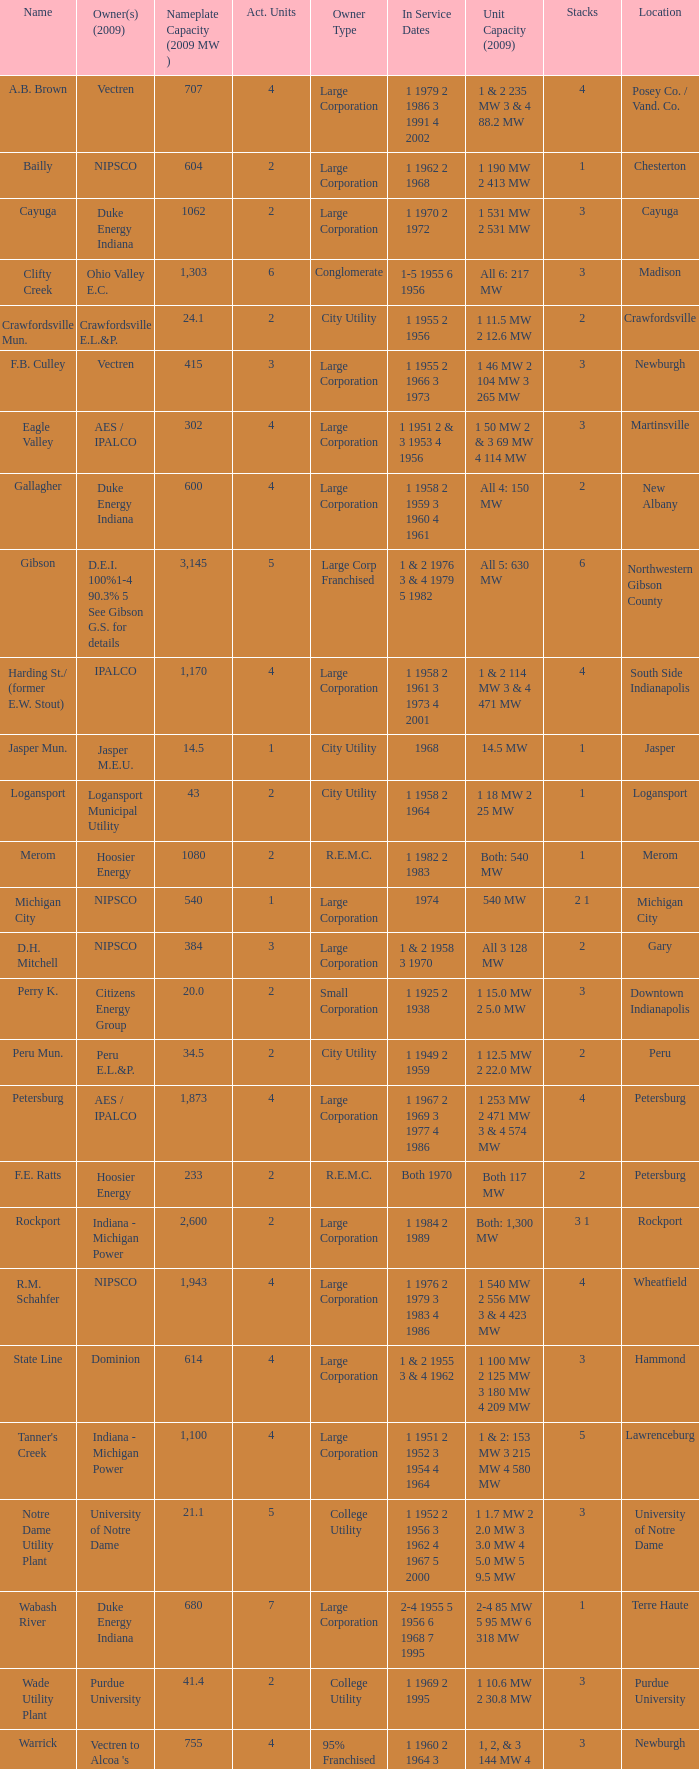Parse the full table. {'header': ['Name', 'Owner(s) (2009)', 'Nameplate Capacity (2009 MW )', 'Act. Units', 'Owner Type', 'In Service Dates', 'Unit Capacity (2009)', 'Stacks', 'Location'], 'rows': [['A.B. Brown', 'Vectren', '707', '4', 'Large Corporation', '1 1979 2 1986 3 1991 4 2002', '1 & 2 235 MW 3 & 4 88.2 MW', '4', 'Posey Co. / Vand. Co.'], ['Bailly', 'NIPSCO', '604', '2', 'Large Corporation', '1 1962 2 1968', '1 190 MW 2 413 MW', '1', 'Chesterton'], ['Cayuga', 'Duke Energy Indiana', '1062', '2', 'Large Corporation', '1 1970 2 1972', '1 531 MW 2 531 MW', '3', 'Cayuga'], ['Clifty Creek', 'Ohio Valley E.C.', '1,303', '6', 'Conglomerate', '1-5 1955 6 1956', 'All 6: 217 MW', '3', 'Madison'], ['Crawfordsville Mun.', 'Crawfordsville E.L.&P.', '24.1', '2', 'City Utility', '1 1955 2 1956', '1 11.5 MW 2 12.6 MW', '2', 'Crawfordsville'], ['F.B. Culley', 'Vectren', '415', '3', 'Large Corporation', '1 1955 2 1966 3 1973', '1 46 MW 2 104 MW 3 265 MW', '3', 'Newburgh'], ['Eagle Valley', 'AES / IPALCO', '302', '4', 'Large Corporation', '1 1951 2 & 3 1953 4 1956', '1 50 MW 2 & 3 69 MW 4 114 MW', '3', 'Martinsville'], ['Gallagher', 'Duke Energy Indiana', '600', '4', 'Large Corporation', '1 1958 2 1959 3 1960 4 1961', 'All 4: 150 MW', '2', 'New Albany'], ['Gibson', 'D.E.I. 100%1-4 90.3% 5 See Gibson G.S. for details', '3,145', '5', 'Large Corp Franchised', '1 & 2 1976 3 & 4 1979 5 1982', 'All 5: 630 MW', '6', 'Northwestern Gibson County'], ['Harding St./ (former E.W. Stout)', 'IPALCO', '1,170', '4', 'Large Corporation', '1 1958 2 1961 3 1973 4 2001', '1 & 2 114 MW 3 & 4 471 MW', '4', 'South Side Indianapolis'], ['Jasper Mun.', 'Jasper M.E.U.', '14.5', '1', 'City Utility', '1968', '14.5 MW', '1', 'Jasper'], ['Logansport', 'Logansport Municipal Utility', '43', '2', 'City Utility', '1 1958 2 1964', '1 18 MW 2 25 MW', '1', 'Logansport'], ['Merom', 'Hoosier Energy', '1080', '2', 'R.E.M.C.', '1 1982 2 1983', 'Both: 540 MW', '1', 'Merom'], ['Michigan City', 'NIPSCO', '540', '1', 'Large Corporation', '1974', '540 MW', '2 1', 'Michigan City'], ['D.H. Mitchell', 'NIPSCO', '384', '3', 'Large Corporation', '1 & 2 1958 3 1970', 'All 3 128 MW', '2', 'Gary'], ['Perry K.', 'Citizens Energy Group', '20.0', '2', 'Small Corporation', '1 1925 2 1938', '1 15.0 MW 2 5.0 MW', '3', 'Downtown Indianapolis'], ['Peru Mun.', 'Peru E.L.&P.', '34.5', '2', 'City Utility', '1 1949 2 1959', '1 12.5 MW 2 22.0 MW', '2', 'Peru'], ['Petersburg', 'AES / IPALCO', '1,873', '4', 'Large Corporation', '1 1967 2 1969 3 1977 4 1986', '1 253 MW 2 471 MW 3 & 4 574 MW', '4', 'Petersburg'], ['F.E. Ratts', 'Hoosier Energy', '233', '2', 'R.E.M.C.', 'Both 1970', 'Both 117 MW', '2', 'Petersburg'], ['Rockport', 'Indiana - Michigan Power', '2,600', '2', 'Large Corporation', '1 1984 2 1989', 'Both: 1,300 MW', '3 1', 'Rockport'], ['R.M. Schahfer', 'NIPSCO', '1,943', '4', 'Large Corporation', '1 1976 2 1979 3 1983 4 1986', '1 540 MW 2 556 MW 3 & 4 423 MW', '4', 'Wheatfield'], ['State Line', 'Dominion', '614', '4', 'Large Corporation', '1 & 2 1955 3 & 4 1962', '1 100 MW 2 125 MW 3 180 MW 4 209 MW', '3', 'Hammond'], ["Tanner's Creek", 'Indiana - Michigan Power', '1,100', '4', 'Large Corporation', '1 1951 2 1952 3 1954 4 1964', '1 & 2: 153 MW 3 215 MW 4 580 MW', '5', 'Lawrenceburg'], ['Notre Dame Utility Plant', 'University of Notre Dame', '21.1', '5', 'College Utility', '1 1952 2 1956 3 1962 4 1967 5 2000', '1 1.7 MW 2 2.0 MW 3 3.0 MW 4 5.0 MW 5 9.5 MW', '3', 'University of Notre Dame'], ['Wabash River', 'Duke Energy Indiana', '680', '7', 'Large Corporation', '2-4 1955 5 1956 6 1968 7 1995', '2-4 85 MW 5 95 MW 6 318 MW', '1', 'Terre Haute'], ['Wade Utility Plant', 'Purdue University', '41.4', '2', 'College Utility', '1 1969 2 1995', '1 10.6 MW 2 30.8 MW', '3', 'Purdue University'], ['Warrick', "Vectren to Alcoa 's Newburgh Smelter", '755', '4', '95% Franchised', '1 1960 2 1964 3 1965 4 1970', '1, 2, & 3 144 MW 4 323 MW', '3', 'Newburgh']]} Name the owners 2009 for south side indianapolis IPALCO. 